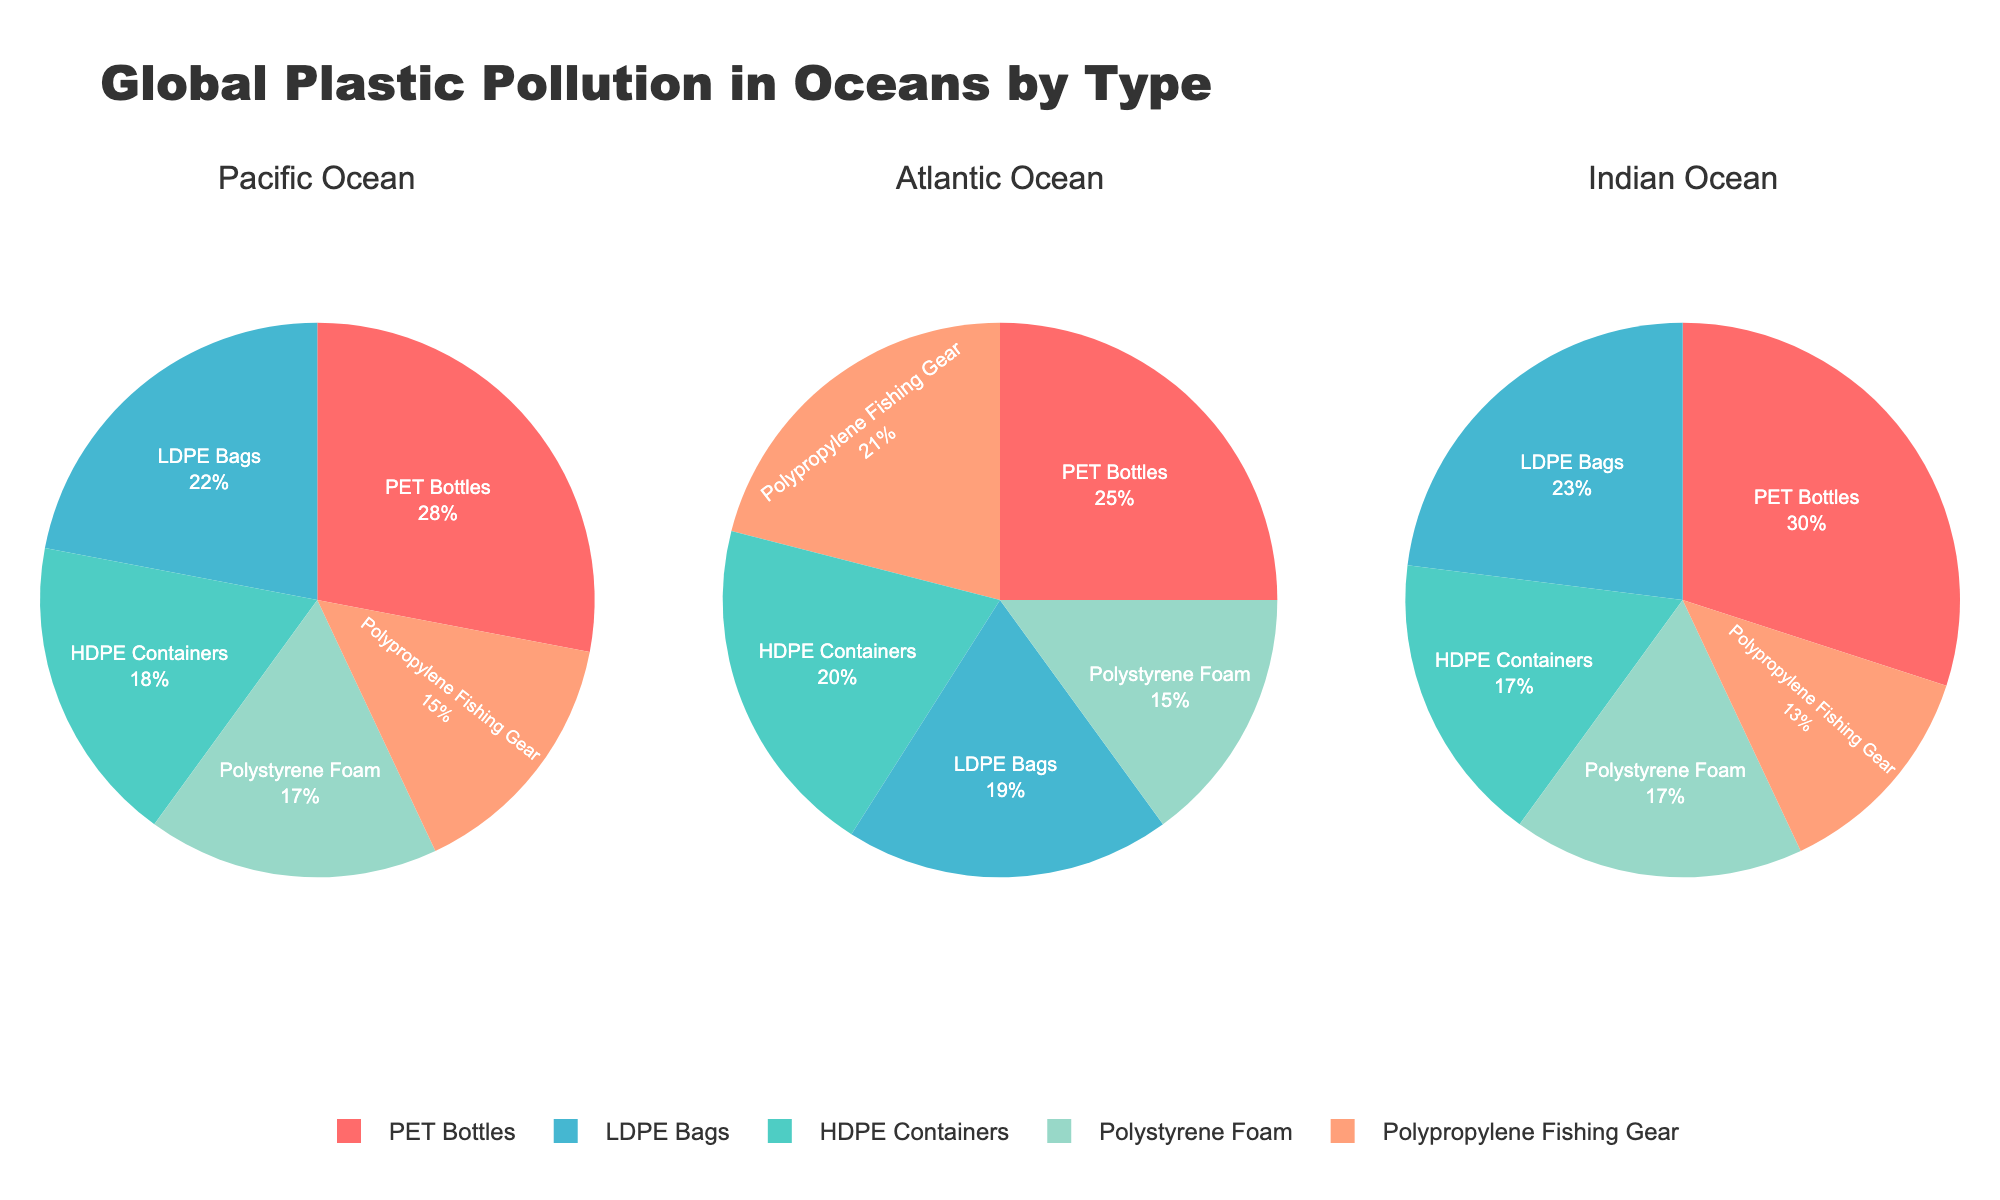What is the most common type of plastic waste in the Pacific Ocean? Looking at the pie chart for the Pacific Ocean, the largest section is labeled "PET Bottles" which indicates it has the highest percentage.
Answer: PET Bottles Which ocean has the highest percentage of LDPE Bags? Comparing the pie charts, the Pacific Ocean has 22%, the Atlantic Ocean has 19%, and the Indian Ocean has 23%. So the Indian Ocean has the highest percentage of LDPE Bags.
Answer: Indian Ocean What is the combined percentage of HDPE Containers and Polystyrene Foam in the Atlantic Ocean? In the Atlantic Ocean pie chart, HDPE Containers have 20% and Polystyrene Foam has 15%. Adding these together gives 20% + 15% = 35%.
Answer: 35% How does the percentage of Polypropylene Fishing Gear in the Indian Ocean compare to the Pacific Ocean? The pie chart indicates that Polypropylene Fishing Gear in the Indian Ocean is 13%, while in the Pacific Ocean it is 15%. Therefore, the Indian Ocean has a lower percentage.
Answer: Indian Ocean is lower Which type of plastic waste has the smallest percentage in the Indian Ocean? Observing the pie chart for the Indian Ocean, Polypropylene Fishing Gear has the smallest section, indicating 13%.
Answer: Polypropylene Fishing Gear What is the total percentage of PET Bottles in all three oceans combined? Add the percentages of PET Bottles for each ocean: Pacific 28%, Atlantic 25%, Indian 30%. Total is 28% + 25% + 30% = 83%.
Answer: 83% Which type of plastic waste is equally prevalent in both the Pacific and Indian Oceans? Polystyrene Foam has 17% in both the Pacific and Indian Oceans, as seen in their respective pie charts.
Answer: Polystyrene Foam Is the percentage of HDPE Containers higher in the Atlantic Ocean or the Pacific Ocean? Comparing the pie charts, HDPE Containers in the Atlantic Ocean have 20%, while in the Pacific Ocean they have 18%. Thus, the Atlantic Ocean has a higher percentage.
Answer: Atlantic Ocean What is the average percentage of PET Bottles in the three oceans? The percentages of PET Bottles are 28% in the Pacific, 25% in the Atlantic, and 30% in the Indian Ocean. The average is (28% + 25% + 30%) / 3 = 27.67%.
Answer: 27.67% 